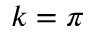<formula> <loc_0><loc_0><loc_500><loc_500>k = \pi</formula> 